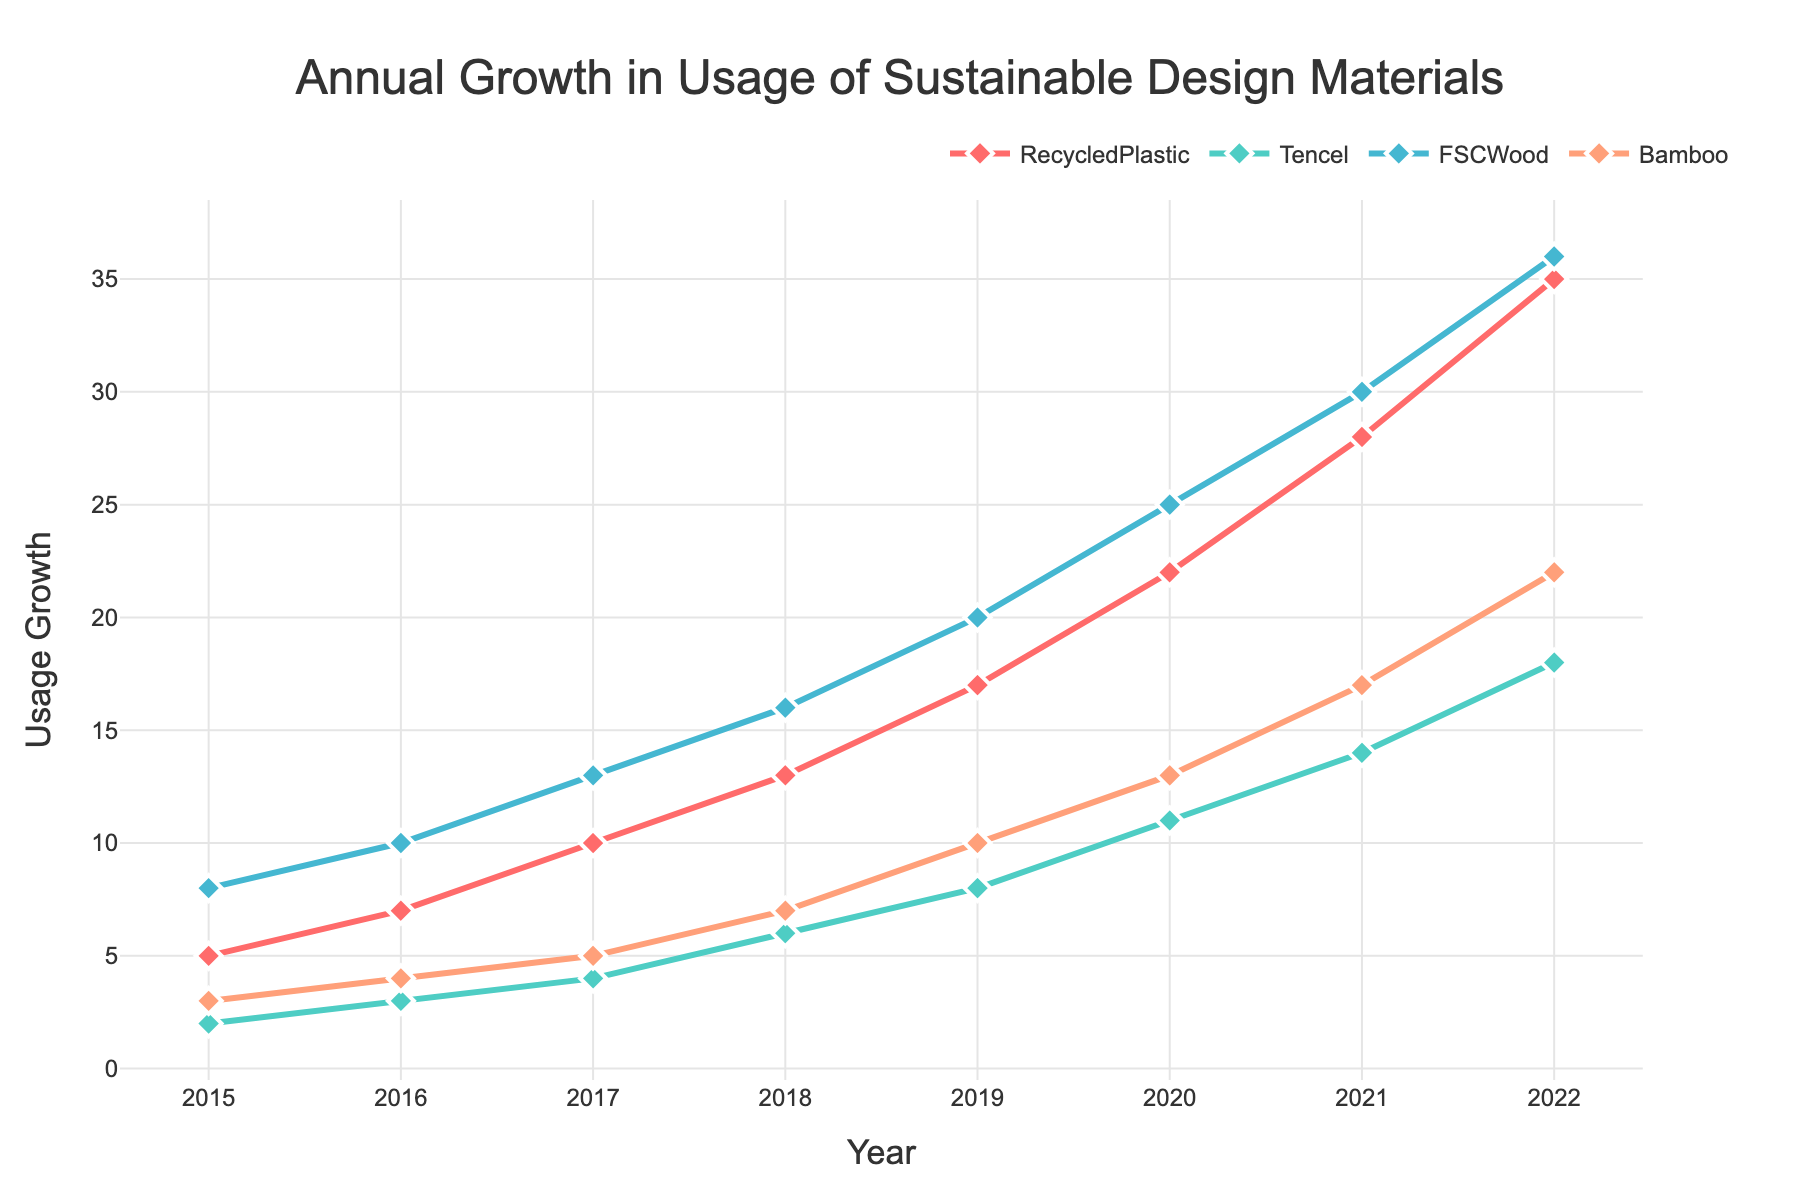What is the title of the time series plot? The title of the plot is located at the top center of the figure. It tells viewers what the plot is about.
Answer: Annual Growth in Usage of Sustainable Design Materials What are the years covered in the plot? The x-axis of the figure shows the range of years covered by the data.
Answer: 2015-2022 Which sustainable design material has the highest growth in the year 2022? To find this, look at the data points for each material in 2022 and identify the highest value.
Answer: RecycledPlastic How many colors are used in the time series plot? The colors of the lines representing each material are visually distinguishable. Count the different colors.
Answer: 4 What is the growth of FSC Wood in 2018? Locate the data marker for FSC Wood in the year 2018 on the plot.
Answer: 16 Which material showed the steepest growth trend over the years? By visually comparing the slopes of the lines, identify the material with the steepest upward trend.
Answer: RecycledPlastic What is the total growth of Bamboo from 2015 to 2022? Add the growth values of Bamboo for each year from 2015 to 2022. Sum up the values (3 + 4 + 5 + 7 + 10 + 13 + 17 + 22).
Answer: 81 Which material showed the least growth in 2017? Look at the data points of each material for 2017 and find the smallest value.
Answer: Tencel Between which years did RecycledPlastic see the highest increase in growth? Calculate the differences in growth between consecutive years for RecycledPlastic and identify the largest increase.
Answer: 2021-2022 What is the average growth of Tencel across the years provided? Add growth values of Tencel for all years and divide by the number of years (2 + 3 + 4 + 6 + 8 + 11 + 14 + 18)/8.
Answer: 8 